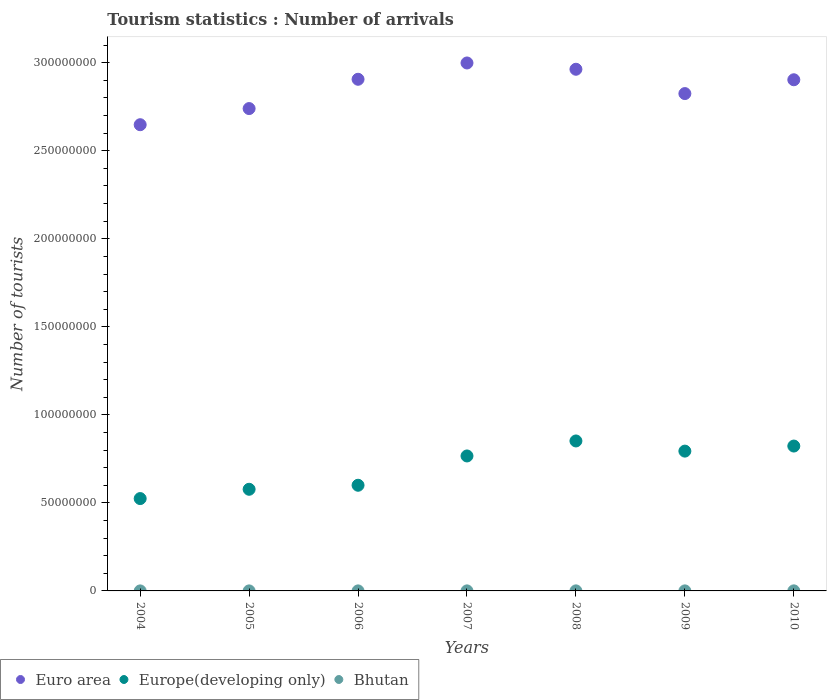Is the number of dotlines equal to the number of legend labels?
Provide a succinct answer. Yes. What is the number of tourist arrivals in Europe(developing only) in 2005?
Your answer should be very brief. 5.77e+07. Across all years, what is the maximum number of tourist arrivals in Euro area?
Give a very brief answer. 3.00e+08. Across all years, what is the minimum number of tourist arrivals in Europe(developing only)?
Offer a terse response. 5.24e+07. In which year was the number of tourist arrivals in Europe(developing only) minimum?
Offer a terse response. 2004. What is the total number of tourist arrivals in Euro area in the graph?
Keep it short and to the point. 2.00e+09. What is the difference between the number of tourist arrivals in Europe(developing only) in 2006 and that in 2008?
Offer a terse response. -2.52e+07. What is the difference between the number of tourist arrivals in Europe(developing only) in 2008 and the number of tourist arrivals in Bhutan in 2009?
Ensure brevity in your answer.  8.52e+07. What is the average number of tourist arrivals in Euro area per year?
Keep it short and to the point. 2.85e+08. In the year 2005, what is the difference between the number of tourist arrivals in Europe(developing only) and number of tourist arrivals in Bhutan?
Offer a terse response. 5.77e+07. In how many years, is the number of tourist arrivals in Euro area greater than 200000000?
Give a very brief answer. 7. What is the ratio of the number of tourist arrivals in Euro area in 2007 to that in 2010?
Ensure brevity in your answer.  1.03. Is the number of tourist arrivals in Bhutan in 2006 less than that in 2010?
Provide a succinct answer. Yes. What is the difference between the highest and the second highest number of tourist arrivals in Bhutan?
Offer a very short reply. 1.30e+04. What is the difference between the highest and the lowest number of tourist arrivals in Euro area?
Offer a very short reply. 3.51e+07. In how many years, is the number of tourist arrivals in Euro area greater than the average number of tourist arrivals in Euro area taken over all years?
Provide a short and direct response. 4. Is the sum of the number of tourist arrivals in Europe(developing only) in 2005 and 2010 greater than the maximum number of tourist arrivals in Euro area across all years?
Provide a short and direct response. No. Is it the case that in every year, the sum of the number of tourist arrivals in Europe(developing only) and number of tourist arrivals in Euro area  is greater than the number of tourist arrivals in Bhutan?
Make the answer very short. Yes. Is the number of tourist arrivals in Bhutan strictly less than the number of tourist arrivals in Euro area over the years?
Your response must be concise. Yes. What is the difference between two consecutive major ticks on the Y-axis?
Your response must be concise. 5.00e+07. What is the title of the graph?
Offer a very short reply. Tourism statistics : Number of arrivals. Does "Liberia" appear as one of the legend labels in the graph?
Your answer should be very brief. No. What is the label or title of the Y-axis?
Offer a very short reply. Number of tourists. What is the Number of tourists of Euro area in 2004?
Offer a very short reply. 2.65e+08. What is the Number of tourists in Europe(developing only) in 2004?
Your response must be concise. 5.24e+07. What is the Number of tourists in Bhutan in 2004?
Make the answer very short. 9000. What is the Number of tourists of Euro area in 2005?
Provide a short and direct response. 2.74e+08. What is the Number of tourists of Europe(developing only) in 2005?
Provide a succinct answer. 5.77e+07. What is the Number of tourists of Bhutan in 2005?
Your answer should be very brief. 1.40e+04. What is the Number of tourists of Euro area in 2006?
Your response must be concise. 2.91e+08. What is the Number of tourists in Europe(developing only) in 2006?
Provide a short and direct response. 6.00e+07. What is the Number of tourists in Bhutan in 2006?
Ensure brevity in your answer.  1.70e+04. What is the Number of tourists of Euro area in 2007?
Provide a succinct answer. 3.00e+08. What is the Number of tourists in Europe(developing only) in 2007?
Keep it short and to the point. 7.67e+07. What is the Number of tourists in Bhutan in 2007?
Offer a very short reply. 2.10e+04. What is the Number of tourists of Euro area in 2008?
Give a very brief answer. 2.96e+08. What is the Number of tourists in Europe(developing only) in 2008?
Make the answer very short. 8.52e+07. What is the Number of tourists in Bhutan in 2008?
Your answer should be compact. 2.80e+04. What is the Number of tourists of Euro area in 2009?
Offer a terse response. 2.82e+08. What is the Number of tourists in Europe(developing only) in 2009?
Offer a terse response. 7.94e+07. What is the Number of tourists of Bhutan in 2009?
Give a very brief answer. 2.30e+04. What is the Number of tourists in Euro area in 2010?
Ensure brevity in your answer.  2.90e+08. What is the Number of tourists in Europe(developing only) in 2010?
Offer a very short reply. 8.23e+07. What is the Number of tourists of Bhutan in 2010?
Provide a short and direct response. 4.10e+04. Across all years, what is the maximum Number of tourists in Euro area?
Offer a terse response. 3.00e+08. Across all years, what is the maximum Number of tourists in Europe(developing only)?
Make the answer very short. 8.52e+07. Across all years, what is the maximum Number of tourists in Bhutan?
Your response must be concise. 4.10e+04. Across all years, what is the minimum Number of tourists of Euro area?
Make the answer very short. 2.65e+08. Across all years, what is the minimum Number of tourists in Europe(developing only)?
Your response must be concise. 5.24e+07. Across all years, what is the minimum Number of tourists in Bhutan?
Make the answer very short. 9000. What is the total Number of tourists in Euro area in the graph?
Your answer should be very brief. 2.00e+09. What is the total Number of tourists in Europe(developing only) in the graph?
Provide a succinct answer. 4.94e+08. What is the total Number of tourists of Bhutan in the graph?
Offer a terse response. 1.53e+05. What is the difference between the Number of tourists of Euro area in 2004 and that in 2005?
Make the answer very short. -9.17e+06. What is the difference between the Number of tourists of Europe(developing only) in 2004 and that in 2005?
Offer a terse response. -5.28e+06. What is the difference between the Number of tourists in Bhutan in 2004 and that in 2005?
Your answer should be very brief. -5000. What is the difference between the Number of tourists in Euro area in 2004 and that in 2006?
Ensure brevity in your answer.  -2.58e+07. What is the difference between the Number of tourists in Europe(developing only) in 2004 and that in 2006?
Your response must be concise. -7.56e+06. What is the difference between the Number of tourists of Bhutan in 2004 and that in 2006?
Give a very brief answer. -8000. What is the difference between the Number of tourists of Euro area in 2004 and that in 2007?
Ensure brevity in your answer.  -3.51e+07. What is the difference between the Number of tourists of Europe(developing only) in 2004 and that in 2007?
Offer a very short reply. -2.42e+07. What is the difference between the Number of tourists of Bhutan in 2004 and that in 2007?
Keep it short and to the point. -1.20e+04. What is the difference between the Number of tourists in Euro area in 2004 and that in 2008?
Your answer should be very brief. -3.15e+07. What is the difference between the Number of tourists of Europe(developing only) in 2004 and that in 2008?
Your answer should be compact. -3.27e+07. What is the difference between the Number of tourists in Bhutan in 2004 and that in 2008?
Keep it short and to the point. -1.90e+04. What is the difference between the Number of tourists of Euro area in 2004 and that in 2009?
Offer a very short reply. -1.77e+07. What is the difference between the Number of tourists of Europe(developing only) in 2004 and that in 2009?
Provide a short and direct response. -2.70e+07. What is the difference between the Number of tourists in Bhutan in 2004 and that in 2009?
Provide a short and direct response. -1.40e+04. What is the difference between the Number of tourists of Euro area in 2004 and that in 2010?
Make the answer very short. -2.55e+07. What is the difference between the Number of tourists in Europe(developing only) in 2004 and that in 2010?
Make the answer very short. -2.98e+07. What is the difference between the Number of tourists in Bhutan in 2004 and that in 2010?
Ensure brevity in your answer.  -3.20e+04. What is the difference between the Number of tourists of Euro area in 2005 and that in 2006?
Make the answer very short. -1.66e+07. What is the difference between the Number of tourists in Europe(developing only) in 2005 and that in 2006?
Your response must be concise. -2.28e+06. What is the difference between the Number of tourists of Bhutan in 2005 and that in 2006?
Keep it short and to the point. -3000. What is the difference between the Number of tourists of Euro area in 2005 and that in 2007?
Provide a succinct answer. -2.59e+07. What is the difference between the Number of tourists of Europe(developing only) in 2005 and that in 2007?
Give a very brief answer. -1.89e+07. What is the difference between the Number of tourists of Bhutan in 2005 and that in 2007?
Give a very brief answer. -7000. What is the difference between the Number of tourists in Euro area in 2005 and that in 2008?
Provide a short and direct response. -2.23e+07. What is the difference between the Number of tourists of Europe(developing only) in 2005 and that in 2008?
Offer a very short reply. -2.74e+07. What is the difference between the Number of tourists in Bhutan in 2005 and that in 2008?
Make the answer very short. -1.40e+04. What is the difference between the Number of tourists in Euro area in 2005 and that in 2009?
Keep it short and to the point. -8.51e+06. What is the difference between the Number of tourists of Europe(developing only) in 2005 and that in 2009?
Give a very brief answer. -2.17e+07. What is the difference between the Number of tourists of Bhutan in 2005 and that in 2009?
Your answer should be compact. -9000. What is the difference between the Number of tourists in Euro area in 2005 and that in 2010?
Offer a terse response. -1.64e+07. What is the difference between the Number of tourists in Europe(developing only) in 2005 and that in 2010?
Offer a very short reply. -2.46e+07. What is the difference between the Number of tourists of Bhutan in 2005 and that in 2010?
Offer a very short reply. -2.70e+04. What is the difference between the Number of tourists in Euro area in 2006 and that in 2007?
Your answer should be very brief. -9.26e+06. What is the difference between the Number of tourists in Europe(developing only) in 2006 and that in 2007?
Ensure brevity in your answer.  -1.66e+07. What is the difference between the Number of tourists in Bhutan in 2006 and that in 2007?
Offer a terse response. -4000. What is the difference between the Number of tourists of Euro area in 2006 and that in 2008?
Your response must be concise. -5.69e+06. What is the difference between the Number of tourists of Europe(developing only) in 2006 and that in 2008?
Provide a succinct answer. -2.52e+07. What is the difference between the Number of tourists in Bhutan in 2006 and that in 2008?
Your response must be concise. -1.10e+04. What is the difference between the Number of tourists in Euro area in 2006 and that in 2009?
Make the answer very short. 8.12e+06. What is the difference between the Number of tourists in Europe(developing only) in 2006 and that in 2009?
Keep it short and to the point. -1.94e+07. What is the difference between the Number of tourists in Bhutan in 2006 and that in 2009?
Your response must be concise. -6000. What is the difference between the Number of tourists of Euro area in 2006 and that in 2010?
Your response must be concise. 2.79e+05. What is the difference between the Number of tourists of Europe(developing only) in 2006 and that in 2010?
Your answer should be compact. -2.23e+07. What is the difference between the Number of tourists of Bhutan in 2006 and that in 2010?
Provide a succinct answer. -2.40e+04. What is the difference between the Number of tourists in Euro area in 2007 and that in 2008?
Provide a short and direct response. 3.57e+06. What is the difference between the Number of tourists in Europe(developing only) in 2007 and that in 2008?
Make the answer very short. -8.52e+06. What is the difference between the Number of tourists of Bhutan in 2007 and that in 2008?
Your answer should be compact. -7000. What is the difference between the Number of tourists of Euro area in 2007 and that in 2009?
Provide a short and direct response. 1.74e+07. What is the difference between the Number of tourists in Europe(developing only) in 2007 and that in 2009?
Make the answer very short. -2.75e+06. What is the difference between the Number of tourists of Bhutan in 2007 and that in 2009?
Ensure brevity in your answer.  -2000. What is the difference between the Number of tourists of Euro area in 2007 and that in 2010?
Your response must be concise. 9.54e+06. What is the difference between the Number of tourists in Europe(developing only) in 2007 and that in 2010?
Keep it short and to the point. -5.63e+06. What is the difference between the Number of tourists of Bhutan in 2007 and that in 2010?
Provide a short and direct response. -2.00e+04. What is the difference between the Number of tourists in Euro area in 2008 and that in 2009?
Offer a terse response. 1.38e+07. What is the difference between the Number of tourists in Europe(developing only) in 2008 and that in 2009?
Provide a succinct answer. 5.77e+06. What is the difference between the Number of tourists in Bhutan in 2008 and that in 2009?
Keep it short and to the point. 5000. What is the difference between the Number of tourists in Euro area in 2008 and that in 2010?
Your answer should be compact. 5.97e+06. What is the difference between the Number of tourists in Europe(developing only) in 2008 and that in 2010?
Ensure brevity in your answer.  2.89e+06. What is the difference between the Number of tourists in Bhutan in 2008 and that in 2010?
Your answer should be compact. -1.30e+04. What is the difference between the Number of tourists of Euro area in 2009 and that in 2010?
Ensure brevity in your answer.  -7.85e+06. What is the difference between the Number of tourists of Europe(developing only) in 2009 and that in 2010?
Your response must be concise. -2.88e+06. What is the difference between the Number of tourists of Bhutan in 2009 and that in 2010?
Provide a short and direct response. -1.80e+04. What is the difference between the Number of tourists in Euro area in 2004 and the Number of tourists in Europe(developing only) in 2005?
Give a very brief answer. 2.07e+08. What is the difference between the Number of tourists of Euro area in 2004 and the Number of tourists of Bhutan in 2005?
Your response must be concise. 2.65e+08. What is the difference between the Number of tourists of Europe(developing only) in 2004 and the Number of tourists of Bhutan in 2005?
Your answer should be compact. 5.24e+07. What is the difference between the Number of tourists in Euro area in 2004 and the Number of tourists in Europe(developing only) in 2006?
Offer a terse response. 2.05e+08. What is the difference between the Number of tourists in Euro area in 2004 and the Number of tourists in Bhutan in 2006?
Your answer should be very brief. 2.65e+08. What is the difference between the Number of tourists of Europe(developing only) in 2004 and the Number of tourists of Bhutan in 2006?
Provide a short and direct response. 5.24e+07. What is the difference between the Number of tourists of Euro area in 2004 and the Number of tourists of Europe(developing only) in 2007?
Your answer should be very brief. 1.88e+08. What is the difference between the Number of tourists of Euro area in 2004 and the Number of tourists of Bhutan in 2007?
Give a very brief answer. 2.65e+08. What is the difference between the Number of tourists in Europe(developing only) in 2004 and the Number of tourists in Bhutan in 2007?
Give a very brief answer. 5.24e+07. What is the difference between the Number of tourists of Euro area in 2004 and the Number of tourists of Europe(developing only) in 2008?
Keep it short and to the point. 1.80e+08. What is the difference between the Number of tourists in Euro area in 2004 and the Number of tourists in Bhutan in 2008?
Give a very brief answer. 2.65e+08. What is the difference between the Number of tourists in Europe(developing only) in 2004 and the Number of tourists in Bhutan in 2008?
Provide a succinct answer. 5.24e+07. What is the difference between the Number of tourists in Euro area in 2004 and the Number of tourists in Europe(developing only) in 2009?
Your response must be concise. 1.85e+08. What is the difference between the Number of tourists of Euro area in 2004 and the Number of tourists of Bhutan in 2009?
Your response must be concise. 2.65e+08. What is the difference between the Number of tourists of Europe(developing only) in 2004 and the Number of tourists of Bhutan in 2009?
Provide a succinct answer. 5.24e+07. What is the difference between the Number of tourists of Euro area in 2004 and the Number of tourists of Europe(developing only) in 2010?
Offer a very short reply. 1.83e+08. What is the difference between the Number of tourists in Euro area in 2004 and the Number of tourists in Bhutan in 2010?
Your response must be concise. 2.65e+08. What is the difference between the Number of tourists of Europe(developing only) in 2004 and the Number of tourists of Bhutan in 2010?
Offer a terse response. 5.24e+07. What is the difference between the Number of tourists of Euro area in 2005 and the Number of tourists of Europe(developing only) in 2006?
Your answer should be very brief. 2.14e+08. What is the difference between the Number of tourists of Euro area in 2005 and the Number of tourists of Bhutan in 2006?
Your response must be concise. 2.74e+08. What is the difference between the Number of tourists in Europe(developing only) in 2005 and the Number of tourists in Bhutan in 2006?
Your answer should be very brief. 5.77e+07. What is the difference between the Number of tourists of Euro area in 2005 and the Number of tourists of Europe(developing only) in 2007?
Offer a terse response. 1.97e+08. What is the difference between the Number of tourists in Euro area in 2005 and the Number of tourists in Bhutan in 2007?
Your answer should be very brief. 2.74e+08. What is the difference between the Number of tourists in Europe(developing only) in 2005 and the Number of tourists in Bhutan in 2007?
Your answer should be compact. 5.77e+07. What is the difference between the Number of tourists of Euro area in 2005 and the Number of tourists of Europe(developing only) in 2008?
Offer a terse response. 1.89e+08. What is the difference between the Number of tourists in Euro area in 2005 and the Number of tourists in Bhutan in 2008?
Offer a terse response. 2.74e+08. What is the difference between the Number of tourists in Europe(developing only) in 2005 and the Number of tourists in Bhutan in 2008?
Keep it short and to the point. 5.77e+07. What is the difference between the Number of tourists of Euro area in 2005 and the Number of tourists of Europe(developing only) in 2009?
Make the answer very short. 1.95e+08. What is the difference between the Number of tourists in Euro area in 2005 and the Number of tourists in Bhutan in 2009?
Make the answer very short. 2.74e+08. What is the difference between the Number of tourists in Europe(developing only) in 2005 and the Number of tourists in Bhutan in 2009?
Your answer should be very brief. 5.77e+07. What is the difference between the Number of tourists in Euro area in 2005 and the Number of tourists in Europe(developing only) in 2010?
Offer a very short reply. 1.92e+08. What is the difference between the Number of tourists in Euro area in 2005 and the Number of tourists in Bhutan in 2010?
Give a very brief answer. 2.74e+08. What is the difference between the Number of tourists in Europe(developing only) in 2005 and the Number of tourists in Bhutan in 2010?
Keep it short and to the point. 5.77e+07. What is the difference between the Number of tourists in Euro area in 2006 and the Number of tourists in Europe(developing only) in 2007?
Offer a terse response. 2.14e+08. What is the difference between the Number of tourists of Euro area in 2006 and the Number of tourists of Bhutan in 2007?
Offer a very short reply. 2.91e+08. What is the difference between the Number of tourists of Europe(developing only) in 2006 and the Number of tourists of Bhutan in 2007?
Offer a terse response. 6.00e+07. What is the difference between the Number of tourists of Euro area in 2006 and the Number of tourists of Europe(developing only) in 2008?
Your answer should be compact. 2.05e+08. What is the difference between the Number of tourists in Euro area in 2006 and the Number of tourists in Bhutan in 2008?
Offer a terse response. 2.91e+08. What is the difference between the Number of tourists in Europe(developing only) in 2006 and the Number of tourists in Bhutan in 2008?
Your response must be concise. 6.00e+07. What is the difference between the Number of tourists in Euro area in 2006 and the Number of tourists in Europe(developing only) in 2009?
Give a very brief answer. 2.11e+08. What is the difference between the Number of tourists in Euro area in 2006 and the Number of tourists in Bhutan in 2009?
Provide a short and direct response. 2.91e+08. What is the difference between the Number of tourists in Europe(developing only) in 2006 and the Number of tourists in Bhutan in 2009?
Ensure brevity in your answer.  6.00e+07. What is the difference between the Number of tourists in Euro area in 2006 and the Number of tourists in Europe(developing only) in 2010?
Keep it short and to the point. 2.08e+08. What is the difference between the Number of tourists of Euro area in 2006 and the Number of tourists of Bhutan in 2010?
Offer a very short reply. 2.91e+08. What is the difference between the Number of tourists of Europe(developing only) in 2006 and the Number of tourists of Bhutan in 2010?
Provide a short and direct response. 6.00e+07. What is the difference between the Number of tourists of Euro area in 2007 and the Number of tourists of Europe(developing only) in 2008?
Provide a succinct answer. 2.15e+08. What is the difference between the Number of tourists of Euro area in 2007 and the Number of tourists of Bhutan in 2008?
Offer a terse response. 3.00e+08. What is the difference between the Number of tourists in Europe(developing only) in 2007 and the Number of tourists in Bhutan in 2008?
Your response must be concise. 7.66e+07. What is the difference between the Number of tourists of Euro area in 2007 and the Number of tourists of Europe(developing only) in 2009?
Give a very brief answer. 2.20e+08. What is the difference between the Number of tourists in Euro area in 2007 and the Number of tourists in Bhutan in 2009?
Provide a short and direct response. 3.00e+08. What is the difference between the Number of tourists in Europe(developing only) in 2007 and the Number of tourists in Bhutan in 2009?
Keep it short and to the point. 7.66e+07. What is the difference between the Number of tourists of Euro area in 2007 and the Number of tourists of Europe(developing only) in 2010?
Your response must be concise. 2.18e+08. What is the difference between the Number of tourists of Euro area in 2007 and the Number of tourists of Bhutan in 2010?
Provide a short and direct response. 3.00e+08. What is the difference between the Number of tourists of Europe(developing only) in 2007 and the Number of tourists of Bhutan in 2010?
Provide a short and direct response. 7.66e+07. What is the difference between the Number of tourists in Euro area in 2008 and the Number of tourists in Europe(developing only) in 2009?
Your answer should be very brief. 2.17e+08. What is the difference between the Number of tourists in Euro area in 2008 and the Number of tourists in Bhutan in 2009?
Make the answer very short. 2.96e+08. What is the difference between the Number of tourists in Europe(developing only) in 2008 and the Number of tourists in Bhutan in 2009?
Offer a very short reply. 8.52e+07. What is the difference between the Number of tourists in Euro area in 2008 and the Number of tourists in Europe(developing only) in 2010?
Ensure brevity in your answer.  2.14e+08. What is the difference between the Number of tourists of Euro area in 2008 and the Number of tourists of Bhutan in 2010?
Your response must be concise. 2.96e+08. What is the difference between the Number of tourists in Europe(developing only) in 2008 and the Number of tourists in Bhutan in 2010?
Provide a succinct answer. 8.51e+07. What is the difference between the Number of tourists of Euro area in 2009 and the Number of tourists of Europe(developing only) in 2010?
Keep it short and to the point. 2.00e+08. What is the difference between the Number of tourists in Euro area in 2009 and the Number of tourists in Bhutan in 2010?
Keep it short and to the point. 2.82e+08. What is the difference between the Number of tourists in Europe(developing only) in 2009 and the Number of tourists in Bhutan in 2010?
Your response must be concise. 7.94e+07. What is the average Number of tourists in Euro area per year?
Provide a short and direct response. 2.85e+08. What is the average Number of tourists in Europe(developing only) per year?
Give a very brief answer. 7.05e+07. What is the average Number of tourists of Bhutan per year?
Your answer should be very brief. 2.19e+04. In the year 2004, what is the difference between the Number of tourists in Euro area and Number of tourists in Europe(developing only)?
Your answer should be very brief. 2.12e+08. In the year 2004, what is the difference between the Number of tourists in Euro area and Number of tourists in Bhutan?
Keep it short and to the point. 2.65e+08. In the year 2004, what is the difference between the Number of tourists in Europe(developing only) and Number of tourists in Bhutan?
Provide a short and direct response. 5.24e+07. In the year 2005, what is the difference between the Number of tourists in Euro area and Number of tourists in Europe(developing only)?
Keep it short and to the point. 2.16e+08. In the year 2005, what is the difference between the Number of tourists of Euro area and Number of tourists of Bhutan?
Make the answer very short. 2.74e+08. In the year 2005, what is the difference between the Number of tourists in Europe(developing only) and Number of tourists in Bhutan?
Provide a succinct answer. 5.77e+07. In the year 2006, what is the difference between the Number of tourists in Euro area and Number of tourists in Europe(developing only)?
Your answer should be compact. 2.31e+08. In the year 2006, what is the difference between the Number of tourists of Euro area and Number of tourists of Bhutan?
Offer a very short reply. 2.91e+08. In the year 2006, what is the difference between the Number of tourists of Europe(developing only) and Number of tourists of Bhutan?
Your answer should be compact. 6.00e+07. In the year 2007, what is the difference between the Number of tourists of Euro area and Number of tourists of Europe(developing only)?
Provide a succinct answer. 2.23e+08. In the year 2007, what is the difference between the Number of tourists in Euro area and Number of tourists in Bhutan?
Your answer should be very brief. 3.00e+08. In the year 2007, what is the difference between the Number of tourists in Europe(developing only) and Number of tourists in Bhutan?
Ensure brevity in your answer.  7.66e+07. In the year 2008, what is the difference between the Number of tourists of Euro area and Number of tourists of Europe(developing only)?
Your answer should be compact. 2.11e+08. In the year 2008, what is the difference between the Number of tourists in Euro area and Number of tourists in Bhutan?
Provide a succinct answer. 2.96e+08. In the year 2008, what is the difference between the Number of tourists in Europe(developing only) and Number of tourists in Bhutan?
Make the answer very short. 8.51e+07. In the year 2009, what is the difference between the Number of tourists of Euro area and Number of tourists of Europe(developing only)?
Your answer should be compact. 2.03e+08. In the year 2009, what is the difference between the Number of tourists in Euro area and Number of tourists in Bhutan?
Make the answer very short. 2.82e+08. In the year 2009, what is the difference between the Number of tourists in Europe(developing only) and Number of tourists in Bhutan?
Offer a terse response. 7.94e+07. In the year 2010, what is the difference between the Number of tourists in Euro area and Number of tourists in Europe(developing only)?
Offer a terse response. 2.08e+08. In the year 2010, what is the difference between the Number of tourists in Euro area and Number of tourists in Bhutan?
Ensure brevity in your answer.  2.90e+08. In the year 2010, what is the difference between the Number of tourists of Europe(developing only) and Number of tourists of Bhutan?
Your answer should be compact. 8.22e+07. What is the ratio of the Number of tourists of Euro area in 2004 to that in 2005?
Provide a succinct answer. 0.97. What is the ratio of the Number of tourists in Europe(developing only) in 2004 to that in 2005?
Make the answer very short. 0.91. What is the ratio of the Number of tourists of Bhutan in 2004 to that in 2005?
Your answer should be compact. 0.64. What is the ratio of the Number of tourists in Euro area in 2004 to that in 2006?
Ensure brevity in your answer.  0.91. What is the ratio of the Number of tourists of Europe(developing only) in 2004 to that in 2006?
Give a very brief answer. 0.87. What is the ratio of the Number of tourists of Bhutan in 2004 to that in 2006?
Provide a succinct answer. 0.53. What is the ratio of the Number of tourists of Euro area in 2004 to that in 2007?
Your answer should be very brief. 0.88. What is the ratio of the Number of tourists of Europe(developing only) in 2004 to that in 2007?
Offer a terse response. 0.68. What is the ratio of the Number of tourists of Bhutan in 2004 to that in 2007?
Offer a terse response. 0.43. What is the ratio of the Number of tourists in Euro area in 2004 to that in 2008?
Offer a very short reply. 0.89. What is the ratio of the Number of tourists of Europe(developing only) in 2004 to that in 2008?
Your answer should be compact. 0.62. What is the ratio of the Number of tourists of Bhutan in 2004 to that in 2008?
Make the answer very short. 0.32. What is the ratio of the Number of tourists of Euro area in 2004 to that in 2009?
Give a very brief answer. 0.94. What is the ratio of the Number of tourists in Europe(developing only) in 2004 to that in 2009?
Provide a succinct answer. 0.66. What is the ratio of the Number of tourists in Bhutan in 2004 to that in 2009?
Your answer should be compact. 0.39. What is the ratio of the Number of tourists of Euro area in 2004 to that in 2010?
Offer a terse response. 0.91. What is the ratio of the Number of tourists in Europe(developing only) in 2004 to that in 2010?
Provide a short and direct response. 0.64. What is the ratio of the Number of tourists of Bhutan in 2004 to that in 2010?
Your response must be concise. 0.22. What is the ratio of the Number of tourists in Euro area in 2005 to that in 2006?
Keep it short and to the point. 0.94. What is the ratio of the Number of tourists in Europe(developing only) in 2005 to that in 2006?
Offer a terse response. 0.96. What is the ratio of the Number of tourists in Bhutan in 2005 to that in 2006?
Keep it short and to the point. 0.82. What is the ratio of the Number of tourists in Euro area in 2005 to that in 2007?
Provide a succinct answer. 0.91. What is the ratio of the Number of tourists of Europe(developing only) in 2005 to that in 2007?
Your answer should be compact. 0.75. What is the ratio of the Number of tourists of Bhutan in 2005 to that in 2007?
Provide a short and direct response. 0.67. What is the ratio of the Number of tourists of Euro area in 2005 to that in 2008?
Make the answer very short. 0.92. What is the ratio of the Number of tourists in Europe(developing only) in 2005 to that in 2008?
Keep it short and to the point. 0.68. What is the ratio of the Number of tourists in Euro area in 2005 to that in 2009?
Keep it short and to the point. 0.97. What is the ratio of the Number of tourists of Europe(developing only) in 2005 to that in 2009?
Give a very brief answer. 0.73. What is the ratio of the Number of tourists in Bhutan in 2005 to that in 2009?
Offer a very short reply. 0.61. What is the ratio of the Number of tourists in Euro area in 2005 to that in 2010?
Make the answer very short. 0.94. What is the ratio of the Number of tourists of Europe(developing only) in 2005 to that in 2010?
Provide a succinct answer. 0.7. What is the ratio of the Number of tourists of Bhutan in 2005 to that in 2010?
Provide a succinct answer. 0.34. What is the ratio of the Number of tourists in Euro area in 2006 to that in 2007?
Your answer should be very brief. 0.97. What is the ratio of the Number of tourists of Europe(developing only) in 2006 to that in 2007?
Offer a very short reply. 0.78. What is the ratio of the Number of tourists in Bhutan in 2006 to that in 2007?
Offer a very short reply. 0.81. What is the ratio of the Number of tourists in Euro area in 2006 to that in 2008?
Offer a very short reply. 0.98. What is the ratio of the Number of tourists in Europe(developing only) in 2006 to that in 2008?
Ensure brevity in your answer.  0.7. What is the ratio of the Number of tourists in Bhutan in 2006 to that in 2008?
Your response must be concise. 0.61. What is the ratio of the Number of tourists in Euro area in 2006 to that in 2009?
Provide a short and direct response. 1.03. What is the ratio of the Number of tourists of Europe(developing only) in 2006 to that in 2009?
Keep it short and to the point. 0.76. What is the ratio of the Number of tourists in Bhutan in 2006 to that in 2009?
Ensure brevity in your answer.  0.74. What is the ratio of the Number of tourists of Europe(developing only) in 2006 to that in 2010?
Your answer should be compact. 0.73. What is the ratio of the Number of tourists in Bhutan in 2006 to that in 2010?
Provide a short and direct response. 0.41. What is the ratio of the Number of tourists in Europe(developing only) in 2007 to that in 2008?
Offer a very short reply. 0.9. What is the ratio of the Number of tourists of Euro area in 2007 to that in 2009?
Provide a short and direct response. 1.06. What is the ratio of the Number of tourists in Europe(developing only) in 2007 to that in 2009?
Make the answer very short. 0.97. What is the ratio of the Number of tourists of Bhutan in 2007 to that in 2009?
Your response must be concise. 0.91. What is the ratio of the Number of tourists in Euro area in 2007 to that in 2010?
Give a very brief answer. 1.03. What is the ratio of the Number of tourists in Europe(developing only) in 2007 to that in 2010?
Your response must be concise. 0.93. What is the ratio of the Number of tourists in Bhutan in 2007 to that in 2010?
Your answer should be compact. 0.51. What is the ratio of the Number of tourists of Euro area in 2008 to that in 2009?
Offer a terse response. 1.05. What is the ratio of the Number of tourists of Europe(developing only) in 2008 to that in 2009?
Give a very brief answer. 1.07. What is the ratio of the Number of tourists of Bhutan in 2008 to that in 2009?
Offer a terse response. 1.22. What is the ratio of the Number of tourists in Euro area in 2008 to that in 2010?
Offer a terse response. 1.02. What is the ratio of the Number of tourists of Europe(developing only) in 2008 to that in 2010?
Provide a succinct answer. 1.04. What is the ratio of the Number of tourists in Bhutan in 2008 to that in 2010?
Keep it short and to the point. 0.68. What is the ratio of the Number of tourists in Euro area in 2009 to that in 2010?
Make the answer very short. 0.97. What is the ratio of the Number of tourists in Bhutan in 2009 to that in 2010?
Ensure brevity in your answer.  0.56. What is the difference between the highest and the second highest Number of tourists in Euro area?
Ensure brevity in your answer.  3.57e+06. What is the difference between the highest and the second highest Number of tourists in Europe(developing only)?
Keep it short and to the point. 2.89e+06. What is the difference between the highest and the second highest Number of tourists in Bhutan?
Your answer should be compact. 1.30e+04. What is the difference between the highest and the lowest Number of tourists in Euro area?
Offer a terse response. 3.51e+07. What is the difference between the highest and the lowest Number of tourists in Europe(developing only)?
Make the answer very short. 3.27e+07. What is the difference between the highest and the lowest Number of tourists in Bhutan?
Offer a very short reply. 3.20e+04. 